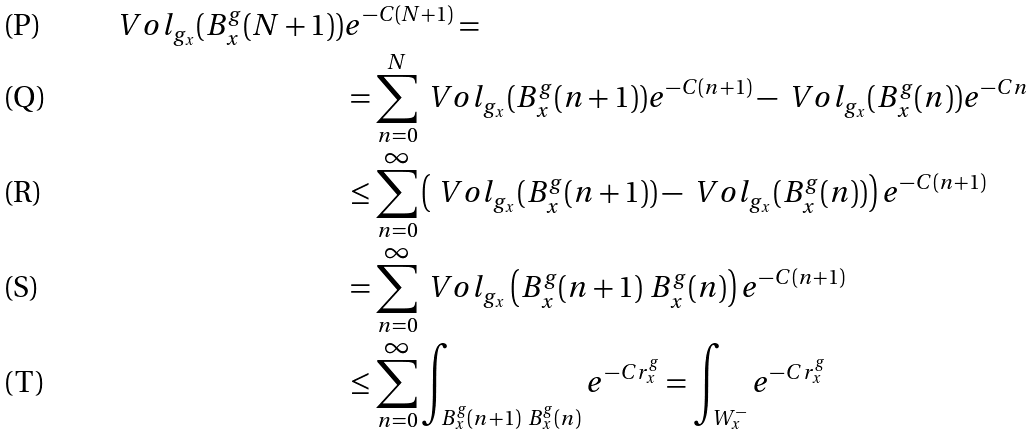<formula> <loc_0><loc_0><loc_500><loc_500>\ V o l _ { g _ { x } } ( B ^ { g } _ { x } ( N + 1 ) ) & e ^ { - C ( N + 1 ) } = \\ & = \sum _ { n = 0 } ^ { N } \ V o l _ { g _ { x } } ( B _ { x } ^ { g } ( n + 1 ) ) e ^ { - C ( n + 1 ) } - \ V o l _ { g _ { x } } ( B _ { x } ^ { g } ( n ) ) e ^ { - C n } \\ & \leq \sum _ { n = 0 } ^ { \infty } \left ( \ V o l _ { g _ { x } } ( B _ { x } ^ { g } ( n + 1 ) ) - \ V o l _ { g _ { x } } ( B _ { x } ^ { g } ( n ) ) \right ) e ^ { - C ( n + 1 ) } \\ & = \sum _ { n = 0 } ^ { \infty } \ V o l _ { g _ { x } } \left ( B _ { x } ^ { g } ( n + 1 ) \ B _ { x } ^ { g } ( n ) \right ) e ^ { - C ( n + 1 ) } \\ & \leq \sum _ { n = 0 } ^ { \infty } \int _ { B _ { x } ^ { g } ( n + 1 ) \ B _ { x } ^ { g } ( n ) } e ^ { - C r _ { x } ^ { g } } = \int _ { W ^ { - } _ { x } } e ^ { - C r _ { x } ^ { g } }</formula> 